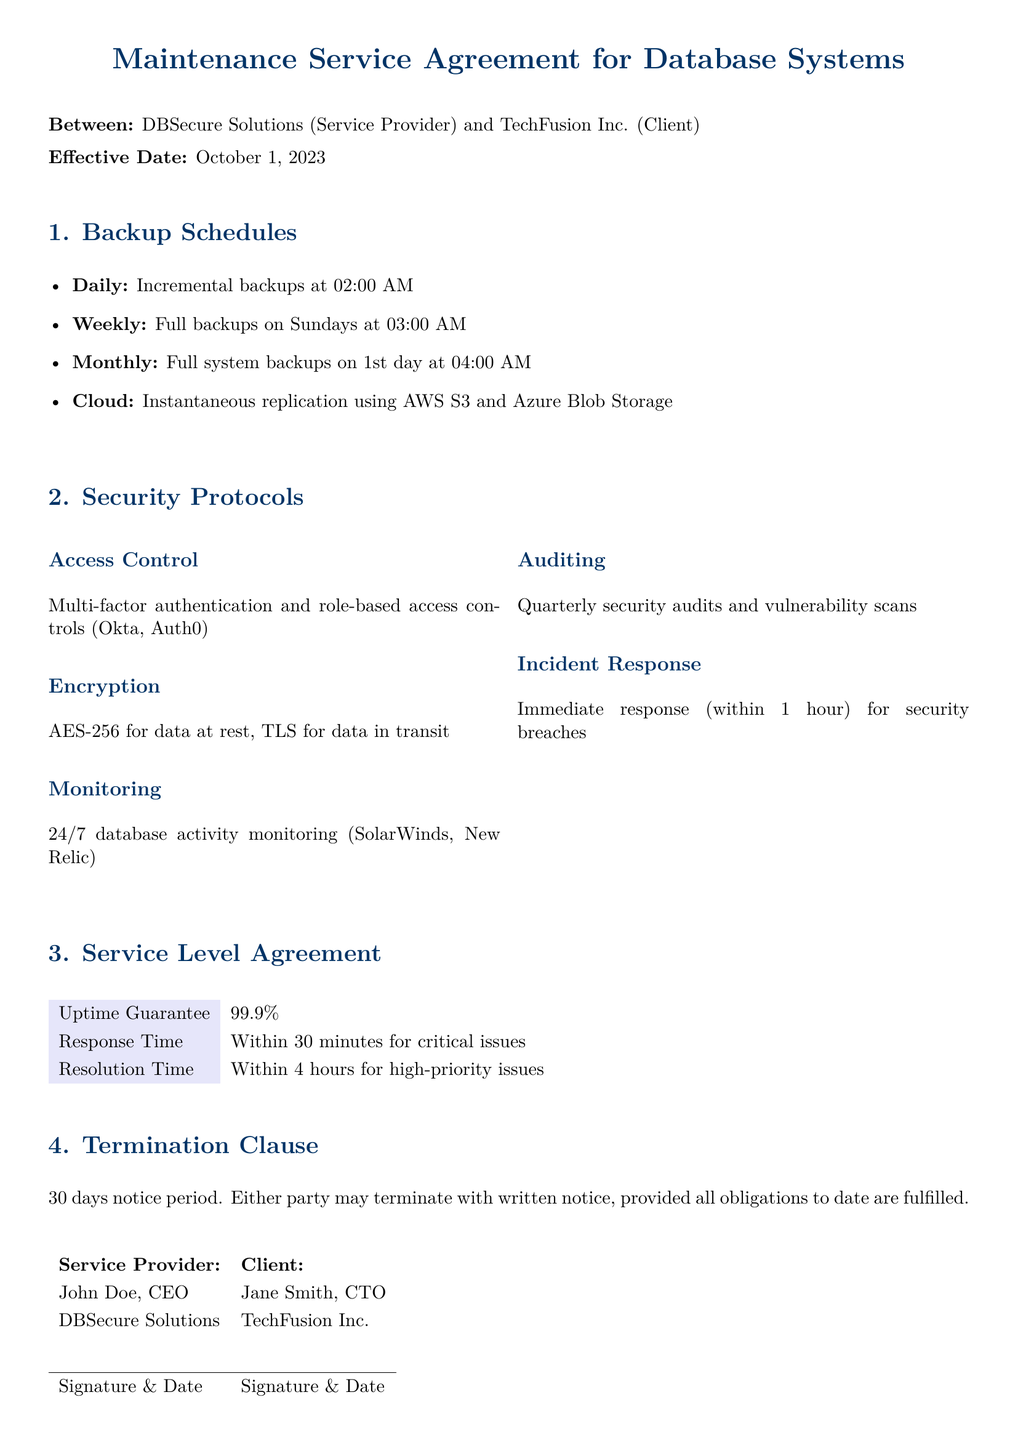What is the effective date of the contract? The effective date is explicitly stated at the beginning of the contract.
Answer: October 1, 2023 How often are incremental backups scheduled? The document outlines the backup schedules, and incremental backups are specifically mentioned.
Answer: Daily Which service provider is mentioned in the agreement? The title states both parties, and the service provider is identified in the introduction.
Answer: DBSecure Solutions What is the uptime guarantee percentage? The Service Level Agreement section details the uptime guarantee provided in the document.
Answer: 99.9% What is the incident response time for security breaches? The security protocols include a specific time frame for responding to security incidents.
Answer: Within 1 hour How many days' notice is needed for termination? The termination clause specifies the required notice period for either party to terminate the agreement.
Answer: 30 days What type of encryption is used for data at rest? The security protocols section details the encryption methods, identifying the type for data at rest.
Answer: AES-256 What is the resolution time for high-priority issues? The Service Level Agreement specifies resolution times for different issues, including high-priority ones.
Answer: Within 4 hours 